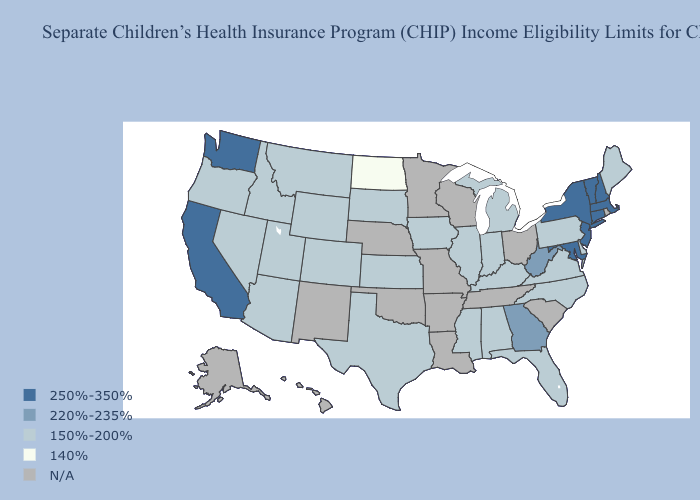Does West Virginia have the lowest value in the South?
Short answer required. No. Does Maryland have the lowest value in the South?
Answer briefly. No. What is the value of Delaware?
Answer briefly. 150%-200%. Among the states that border Massachusetts , which have the highest value?
Be succinct. Connecticut, New Hampshire, New York, Vermont. Does the first symbol in the legend represent the smallest category?
Give a very brief answer. No. What is the value of Alaska?
Keep it brief. N/A. Among the states that border Utah , which have the highest value?
Be succinct. Arizona, Colorado, Idaho, Nevada, Wyoming. What is the value of South Carolina?
Be succinct. N/A. Which states have the lowest value in the USA?
Short answer required. North Dakota. What is the highest value in the Northeast ?
Write a very short answer. 250%-350%. 